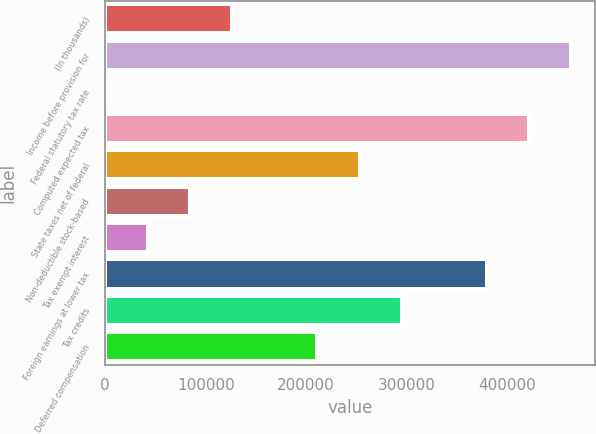Convert chart. <chart><loc_0><loc_0><loc_500><loc_500><bar_chart><fcel>(In thousands)<fcel>Income before provision for<fcel>Federal statutory tax rate<fcel>Computed expected tax<fcel>State taxes net of federal<fcel>Non-deductible stock-based<fcel>Tax exempt interest<fcel>Foreign earnings at lower tax<fcel>Tax credits<fcel>Deferred compensation<nl><fcel>126554<fcel>463938<fcel>35<fcel>421765<fcel>253073<fcel>84381<fcel>42208<fcel>379592<fcel>295246<fcel>210900<nl></chart> 